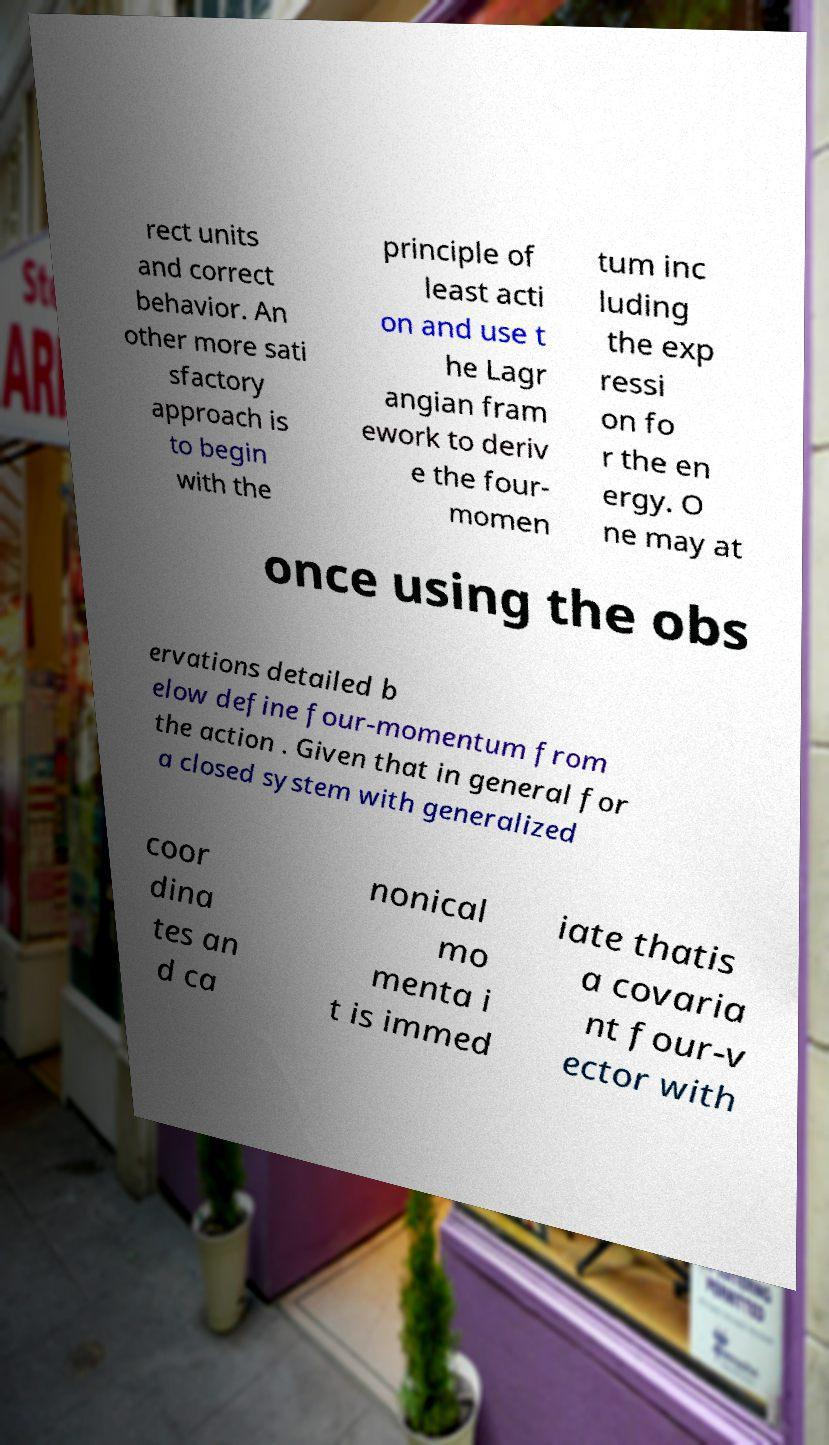For documentation purposes, I need the text within this image transcribed. Could you provide that? rect units and correct behavior. An other more sati sfactory approach is to begin with the principle of least acti on and use t he Lagr angian fram ework to deriv e the four- momen tum inc luding the exp ressi on fo r the en ergy. O ne may at once using the obs ervations detailed b elow define four-momentum from the action . Given that in general for a closed system with generalized coor dina tes an d ca nonical mo menta i t is immed iate thatis a covaria nt four-v ector with 